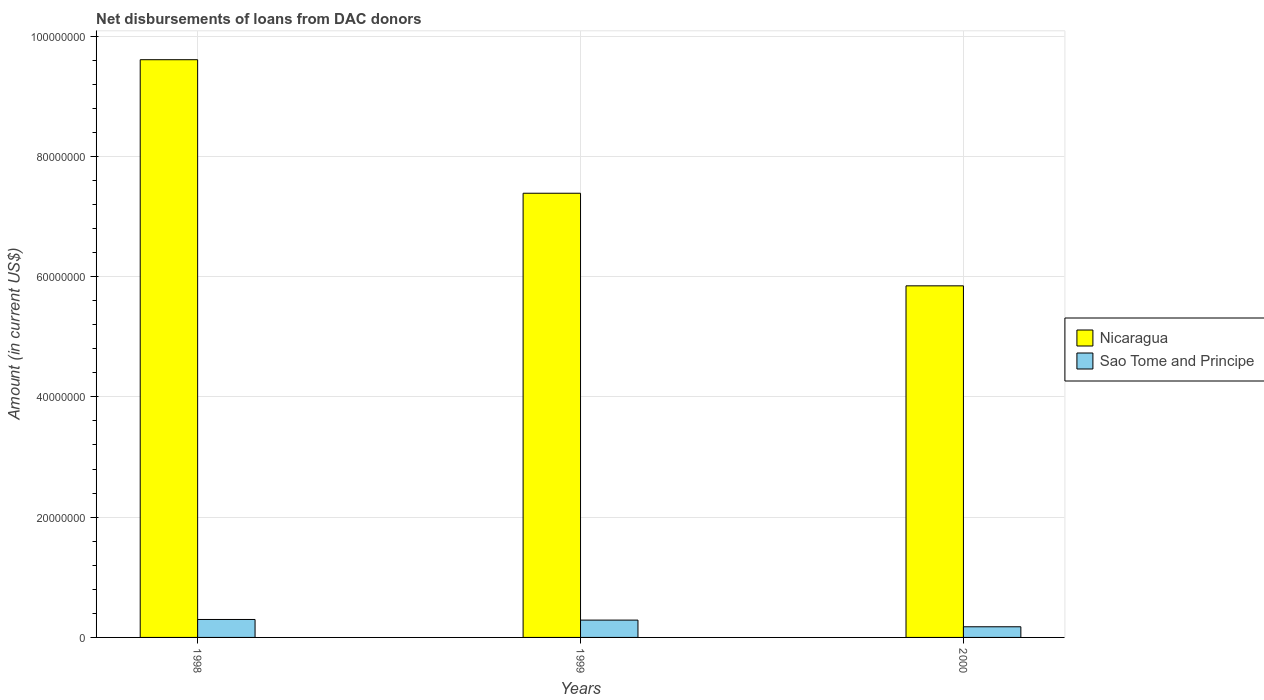What is the label of the 1st group of bars from the left?
Provide a short and direct response. 1998. What is the amount of loans disbursed in Sao Tome and Principe in 2000?
Offer a very short reply. 1.77e+06. Across all years, what is the maximum amount of loans disbursed in Nicaragua?
Make the answer very short. 9.61e+07. Across all years, what is the minimum amount of loans disbursed in Nicaragua?
Provide a succinct answer. 5.85e+07. In which year was the amount of loans disbursed in Sao Tome and Principe minimum?
Give a very brief answer. 2000. What is the total amount of loans disbursed in Sao Tome and Principe in the graph?
Provide a succinct answer. 7.64e+06. What is the difference between the amount of loans disbursed in Sao Tome and Principe in 1999 and that in 2000?
Your answer should be very brief. 1.11e+06. What is the difference between the amount of loans disbursed in Nicaragua in 2000 and the amount of loans disbursed in Sao Tome and Principe in 1998?
Your response must be concise. 5.55e+07. What is the average amount of loans disbursed in Sao Tome and Principe per year?
Provide a succinct answer. 2.55e+06. In the year 2000, what is the difference between the amount of loans disbursed in Nicaragua and amount of loans disbursed in Sao Tome and Principe?
Your answer should be compact. 5.67e+07. What is the ratio of the amount of loans disbursed in Nicaragua in 1998 to that in 2000?
Offer a terse response. 1.64. Is the difference between the amount of loans disbursed in Nicaragua in 1999 and 2000 greater than the difference between the amount of loans disbursed in Sao Tome and Principe in 1999 and 2000?
Keep it short and to the point. Yes. What is the difference between the highest and the second highest amount of loans disbursed in Nicaragua?
Ensure brevity in your answer.  2.22e+07. What is the difference between the highest and the lowest amount of loans disbursed in Nicaragua?
Keep it short and to the point. 3.76e+07. What does the 2nd bar from the left in 1999 represents?
Your answer should be very brief. Sao Tome and Principe. What does the 2nd bar from the right in 2000 represents?
Offer a terse response. Nicaragua. How many bars are there?
Your response must be concise. 6. How many years are there in the graph?
Give a very brief answer. 3. What is the difference between two consecutive major ticks on the Y-axis?
Provide a succinct answer. 2.00e+07. Are the values on the major ticks of Y-axis written in scientific E-notation?
Provide a succinct answer. No. Does the graph contain any zero values?
Keep it short and to the point. No. What is the title of the graph?
Ensure brevity in your answer.  Net disbursements of loans from DAC donors. What is the label or title of the X-axis?
Your response must be concise. Years. What is the label or title of the Y-axis?
Your answer should be very brief. Amount (in current US$). What is the Amount (in current US$) in Nicaragua in 1998?
Offer a terse response. 9.61e+07. What is the Amount (in current US$) in Sao Tome and Principe in 1998?
Ensure brevity in your answer.  2.98e+06. What is the Amount (in current US$) of Nicaragua in 1999?
Offer a very short reply. 7.39e+07. What is the Amount (in current US$) in Sao Tome and Principe in 1999?
Keep it short and to the point. 2.88e+06. What is the Amount (in current US$) in Nicaragua in 2000?
Provide a succinct answer. 5.85e+07. What is the Amount (in current US$) of Sao Tome and Principe in 2000?
Offer a terse response. 1.77e+06. Across all years, what is the maximum Amount (in current US$) in Nicaragua?
Offer a terse response. 9.61e+07. Across all years, what is the maximum Amount (in current US$) of Sao Tome and Principe?
Ensure brevity in your answer.  2.98e+06. Across all years, what is the minimum Amount (in current US$) in Nicaragua?
Keep it short and to the point. 5.85e+07. Across all years, what is the minimum Amount (in current US$) of Sao Tome and Principe?
Provide a short and direct response. 1.77e+06. What is the total Amount (in current US$) in Nicaragua in the graph?
Keep it short and to the point. 2.28e+08. What is the total Amount (in current US$) in Sao Tome and Principe in the graph?
Provide a short and direct response. 7.64e+06. What is the difference between the Amount (in current US$) of Nicaragua in 1998 and that in 1999?
Provide a succinct answer. 2.22e+07. What is the difference between the Amount (in current US$) in Sao Tome and Principe in 1998 and that in 1999?
Provide a succinct answer. 1.05e+05. What is the difference between the Amount (in current US$) of Nicaragua in 1998 and that in 2000?
Ensure brevity in your answer.  3.76e+07. What is the difference between the Amount (in current US$) in Sao Tome and Principe in 1998 and that in 2000?
Provide a short and direct response. 1.21e+06. What is the difference between the Amount (in current US$) of Nicaragua in 1999 and that in 2000?
Your answer should be very brief. 1.54e+07. What is the difference between the Amount (in current US$) of Sao Tome and Principe in 1999 and that in 2000?
Your answer should be very brief. 1.11e+06. What is the difference between the Amount (in current US$) of Nicaragua in 1998 and the Amount (in current US$) of Sao Tome and Principe in 1999?
Provide a succinct answer. 9.32e+07. What is the difference between the Amount (in current US$) of Nicaragua in 1998 and the Amount (in current US$) of Sao Tome and Principe in 2000?
Provide a succinct answer. 9.43e+07. What is the difference between the Amount (in current US$) of Nicaragua in 1999 and the Amount (in current US$) of Sao Tome and Principe in 2000?
Your response must be concise. 7.21e+07. What is the average Amount (in current US$) in Nicaragua per year?
Your response must be concise. 7.61e+07. What is the average Amount (in current US$) of Sao Tome and Principe per year?
Provide a short and direct response. 2.55e+06. In the year 1998, what is the difference between the Amount (in current US$) in Nicaragua and Amount (in current US$) in Sao Tome and Principe?
Offer a terse response. 9.31e+07. In the year 1999, what is the difference between the Amount (in current US$) in Nicaragua and Amount (in current US$) in Sao Tome and Principe?
Offer a terse response. 7.10e+07. In the year 2000, what is the difference between the Amount (in current US$) in Nicaragua and Amount (in current US$) in Sao Tome and Principe?
Your response must be concise. 5.67e+07. What is the ratio of the Amount (in current US$) in Nicaragua in 1998 to that in 1999?
Offer a terse response. 1.3. What is the ratio of the Amount (in current US$) in Sao Tome and Principe in 1998 to that in 1999?
Keep it short and to the point. 1.04. What is the ratio of the Amount (in current US$) in Nicaragua in 1998 to that in 2000?
Make the answer very short. 1.64. What is the ratio of the Amount (in current US$) of Sao Tome and Principe in 1998 to that in 2000?
Offer a terse response. 1.68. What is the ratio of the Amount (in current US$) in Nicaragua in 1999 to that in 2000?
Provide a short and direct response. 1.26. What is the ratio of the Amount (in current US$) in Sao Tome and Principe in 1999 to that in 2000?
Give a very brief answer. 1.63. What is the difference between the highest and the second highest Amount (in current US$) in Nicaragua?
Offer a terse response. 2.22e+07. What is the difference between the highest and the second highest Amount (in current US$) of Sao Tome and Principe?
Provide a short and direct response. 1.05e+05. What is the difference between the highest and the lowest Amount (in current US$) in Nicaragua?
Your answer should be compact. 3.76e+07. What is the difference between the highest and the lowest Amount (in current US$) in Sao Tome and Principe?
Keep it short and to the point. 1.21e+06. 